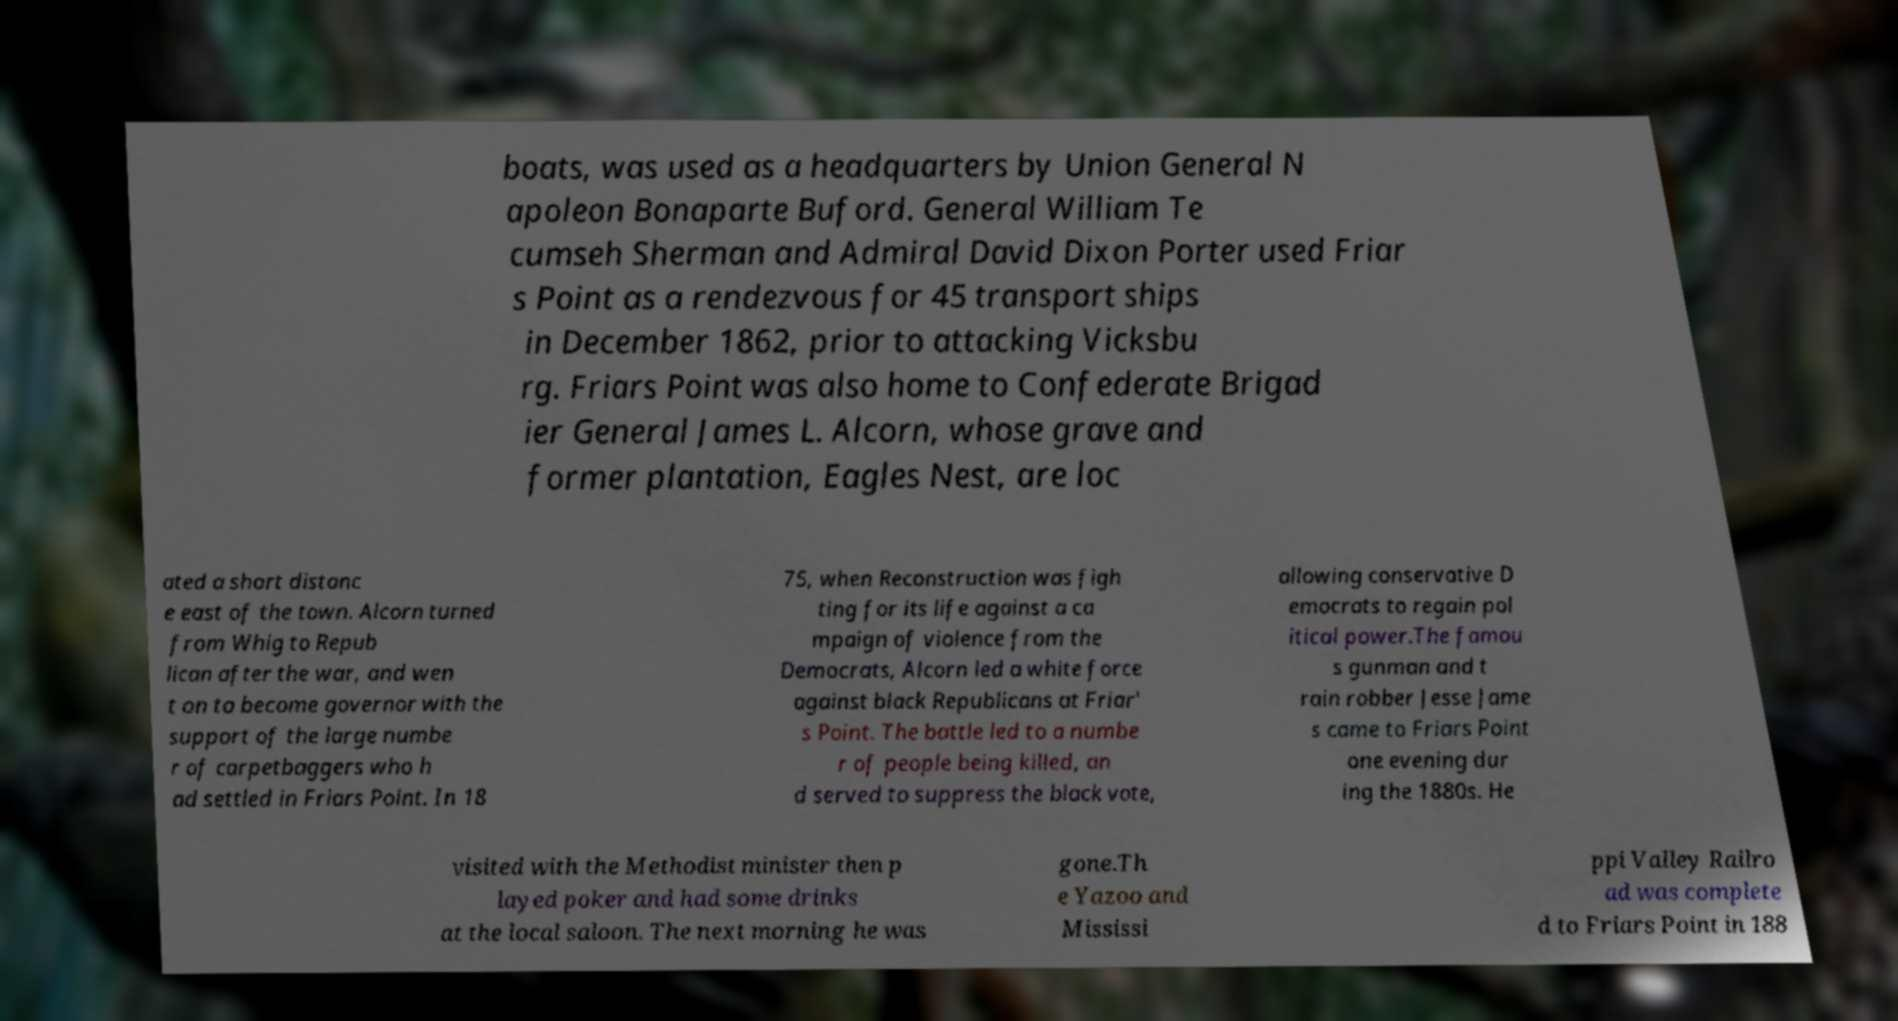Could you extract and type out the text from this image? boats, was used as a headquarters by Union General N apoleon Bonaparte Buford. General William Te cumseh Sherman and Admiral David Dixon Porter used Friar s Point as a rendezvous for 45 transport ships in December 1862, prior to attacking Vicksbu rg. Friars Point was also home to Confederate Brigad ier General James L. Alcorn, whose grave and former plantation, Eagles Nest, are loc ated a short distanc e east of the town. Alcorn turned from Whig to Repub lican after the war, and wen t on to become governor with the support of the large numbe r of carpetbaggers who h ad settled in Friars Point. In 18 75, when Reconstruction was figh ting for its life against a ca mpaign of violence from the Democrats, Alcorn led a white force against black Republicans at Friar' s Point. The battle led to a numbe r of people being killed, an d served to suppress the black vote, allowing conservative D emocrats to regain pol itical power.The famou s gunman and t rain robber Jesse Jame s came to Friars Point one evening dur ing the 1880s. He visited with the Methodist minister then p layed poker and had some drinks at the local saloon. The next morning he was gone.Th e Yazoo and Mississi ppi Valley Railro ad was complete d to Friars Point in 188 